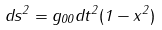Convert formula to latex. <formula><loc_0><loc_0><loc_500><loc_500>d s ^ { 2 } = g _ { 0 0 } d t ^ { 2 } ( 1 - x ^ { 2 } )</formula> 